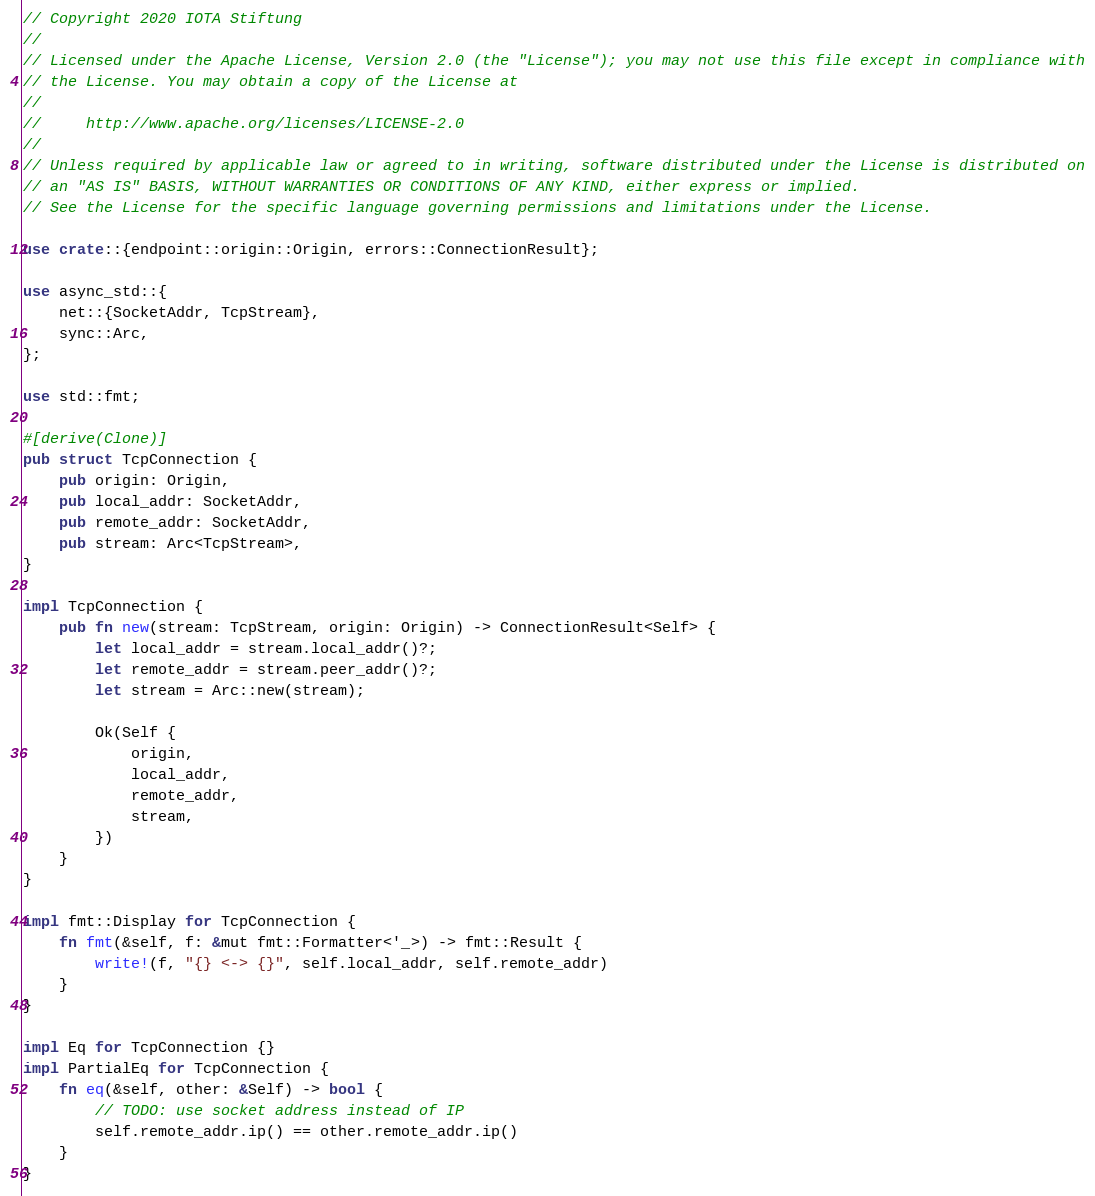<code> <loc_0><loc_0><loc_500><loc_500><_Rust_>// Copyright 2020 IOTA Stiftung
//
// Licensed under the Apache License, Version 2.0 (the "License"); you may not use this file except in compliance with
// the License. You may obtain a copy of the License at
//
//     http://www.apache.org/licenses/LICENSE-2.0
//
// Unless required by applicable law or agreed to in writing, software distributed under the License is distributed on
// an "AS IS" BASIS, WITHOUT WARRANTIES OR CONDITIONS OF ANY KIND, either express or implied.
// See the License for the specific language governing permissions and limitations under the License.

use crate::{endpoint::origin::Origin, errors::ConnectionResult};

use async_std::{
    net::{SocketAddr, TcpStream},
    sync::Arc,
};

use std::fmt;

#[derive(Clone)]
pub struct TcpConnection {
    pub origin: Origin,
    pub local_addr: SocketAddr,
    pub remote_addr: SocketAddr,
    pub stream: Arc<TcpStream>,
}

impl TcpConnection {
    pub fn new(stream: TcpStream, origin: Origin) -> ConnectionResult<Self> {
        let local_addr = stream.local_addr()?;
        let remote_addr = stream.peer_addr()?;
        let stream = Arc::new(stream);

        Ok(Self {
            origin,
            local_addr,
            remote_addr,
            stream,
        })
    }
}

impl fmt::Display for TcpConnection {
    fn fmt(&self, f: &mut fmt::Formatter<'_>) -> fmt::Result {
        write!(f, "{} <-> {}", self.local_addr, self.remote_addr)
    }
}

impl Eq for TcpConnection {}
impl PartialEq for TcpConnection {
    fn eq(&self, other: &Self) -> bool {
        // TODO: use socket address instead of IP
        self.remote_addr.ip() == other.remote_addr.ip()
    }
}
</code> 